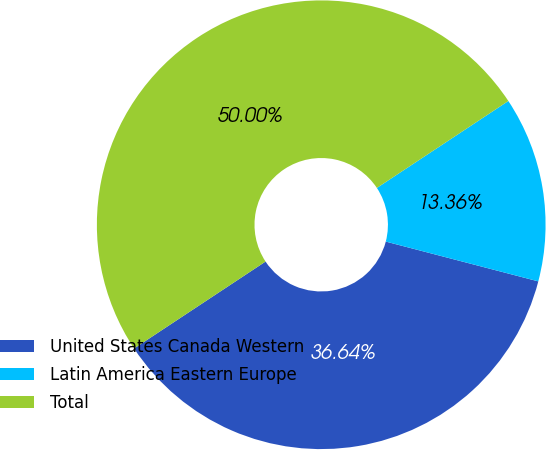<chart> <loc_0><loc_0><loc_500><loc_500><pie_chart><fcel>United States Canada Western<fcel>Latin America Eastern Europe<fcel>Total<nl><fcel>36.64%<fcel>13.36%<fcel>50.0%<nl></chart> 